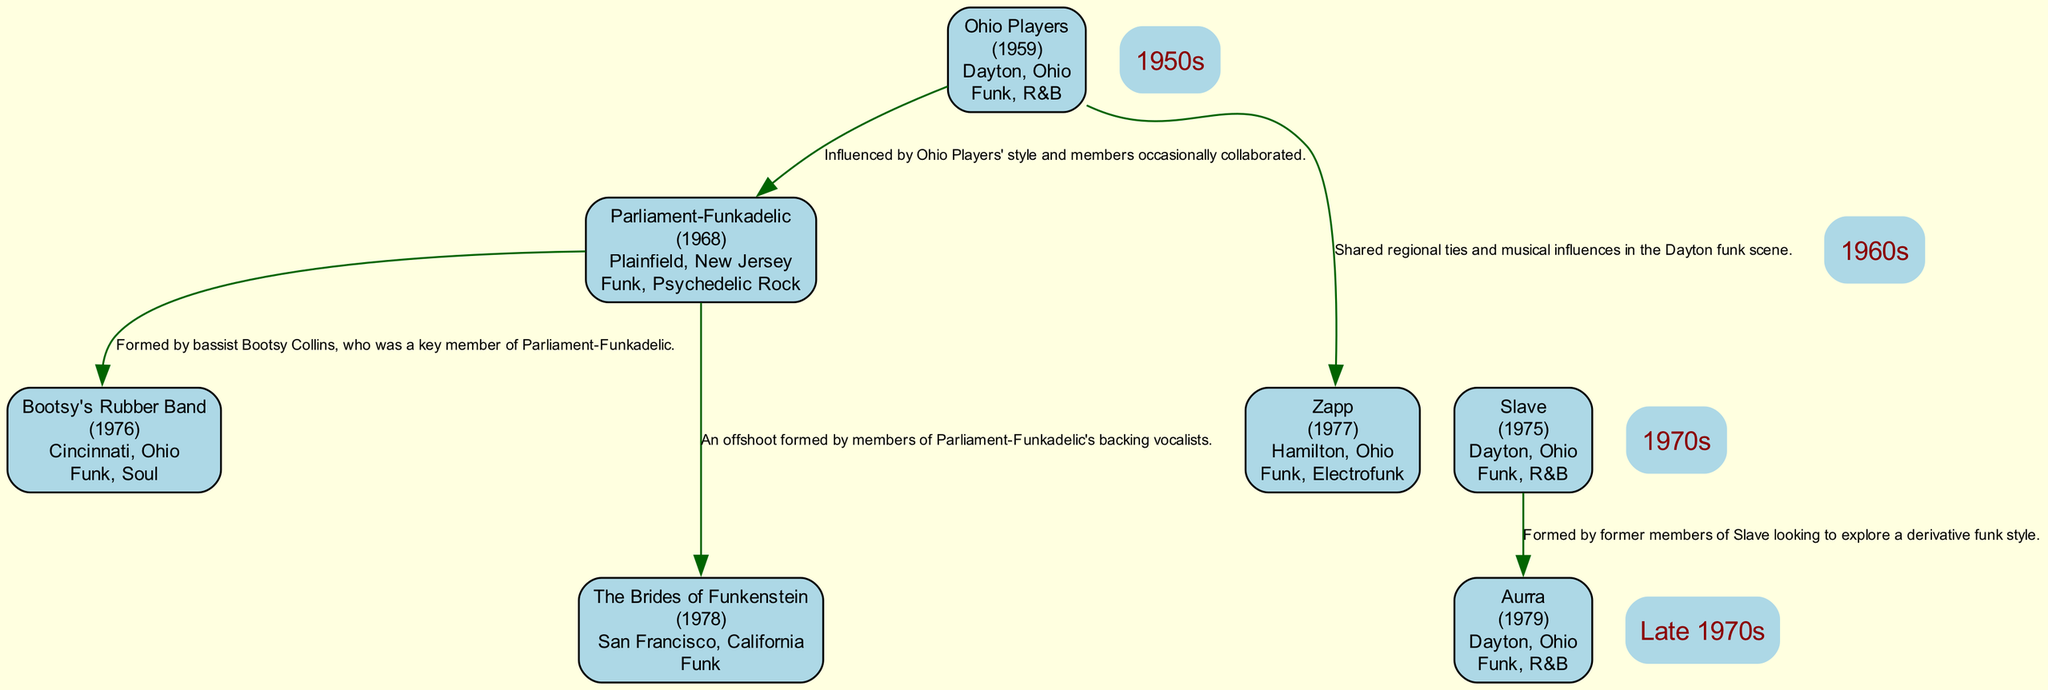What year were the Ohio Players formed? The diagram shows that the Ohio Players were formed in 1959, as indicated next to their name in the band list.
Answer: 1959 Which band is a descendant of Slave? In the descendant bands section of the Slave entry, it lists Aurra as its descendant. Thus, Aurra is the only band connected to Slave.
Answer: Aurra What genre is Zapp primarily known for? The diagram specifies that Zapp's genres include Funk and Electrofunk, which are indicated along with their name.
Answer: Funk, Electrofunk Which band did Bootsy's Rubber Band originate from? According to the diagram, Bootsy's Rubber Band was formed by Bootsy Collins, a key member of Parliament-Funkadelic, indicating the direct lineage.
Answer: Parliament-Funkadelic How many members were in the Ohio Players? The diagram lists five members for the Ohio Players: Leroy 'Sugarfoot' Bonner, Marshall Jones, Ralph 'Pee Wee' Middlebrooks, Clarence Satchell, and James 'Diamond' Williams. Therefore, counting these names gives us five members.
Answer: 5 Which two bands are directly connected to the Ohio Players? The connections on the diagram indicate that the Ohio Players are directly connected to Parliament-Funkadelic and Zapp. This is shown with edges pointing to both bands from Ohio Players.
Answer: Parliament-Funkadelic, Zapp What is the origin city of the Brides of Funkenstein? The diagram reveals that The Brides of Funkenstein originated from San Francisco, California, mentioned next to the band's name.
Answer: San Francisco, California Which band formed in 1978? The diagram specifies that The Brides of Funkenstein was formed in 1978, which is clearly stated in the band's information.
Answer: The Brides of Funkenstein What is the connection between Slave and Aurra? The diagram describes that Aurra was formed by former members of Slave, which indicates a direct musical lineage from Slave to Aurra.
Answer: Former members of Slave How many bands are listed as descendants of Parliament-Funkadelic? From the diagram, it can be seen that Parliament-Funkadelic has two descendant bands: Bootsy's Rubber Band and The Brides of Funkenstein.
Answer: 2 